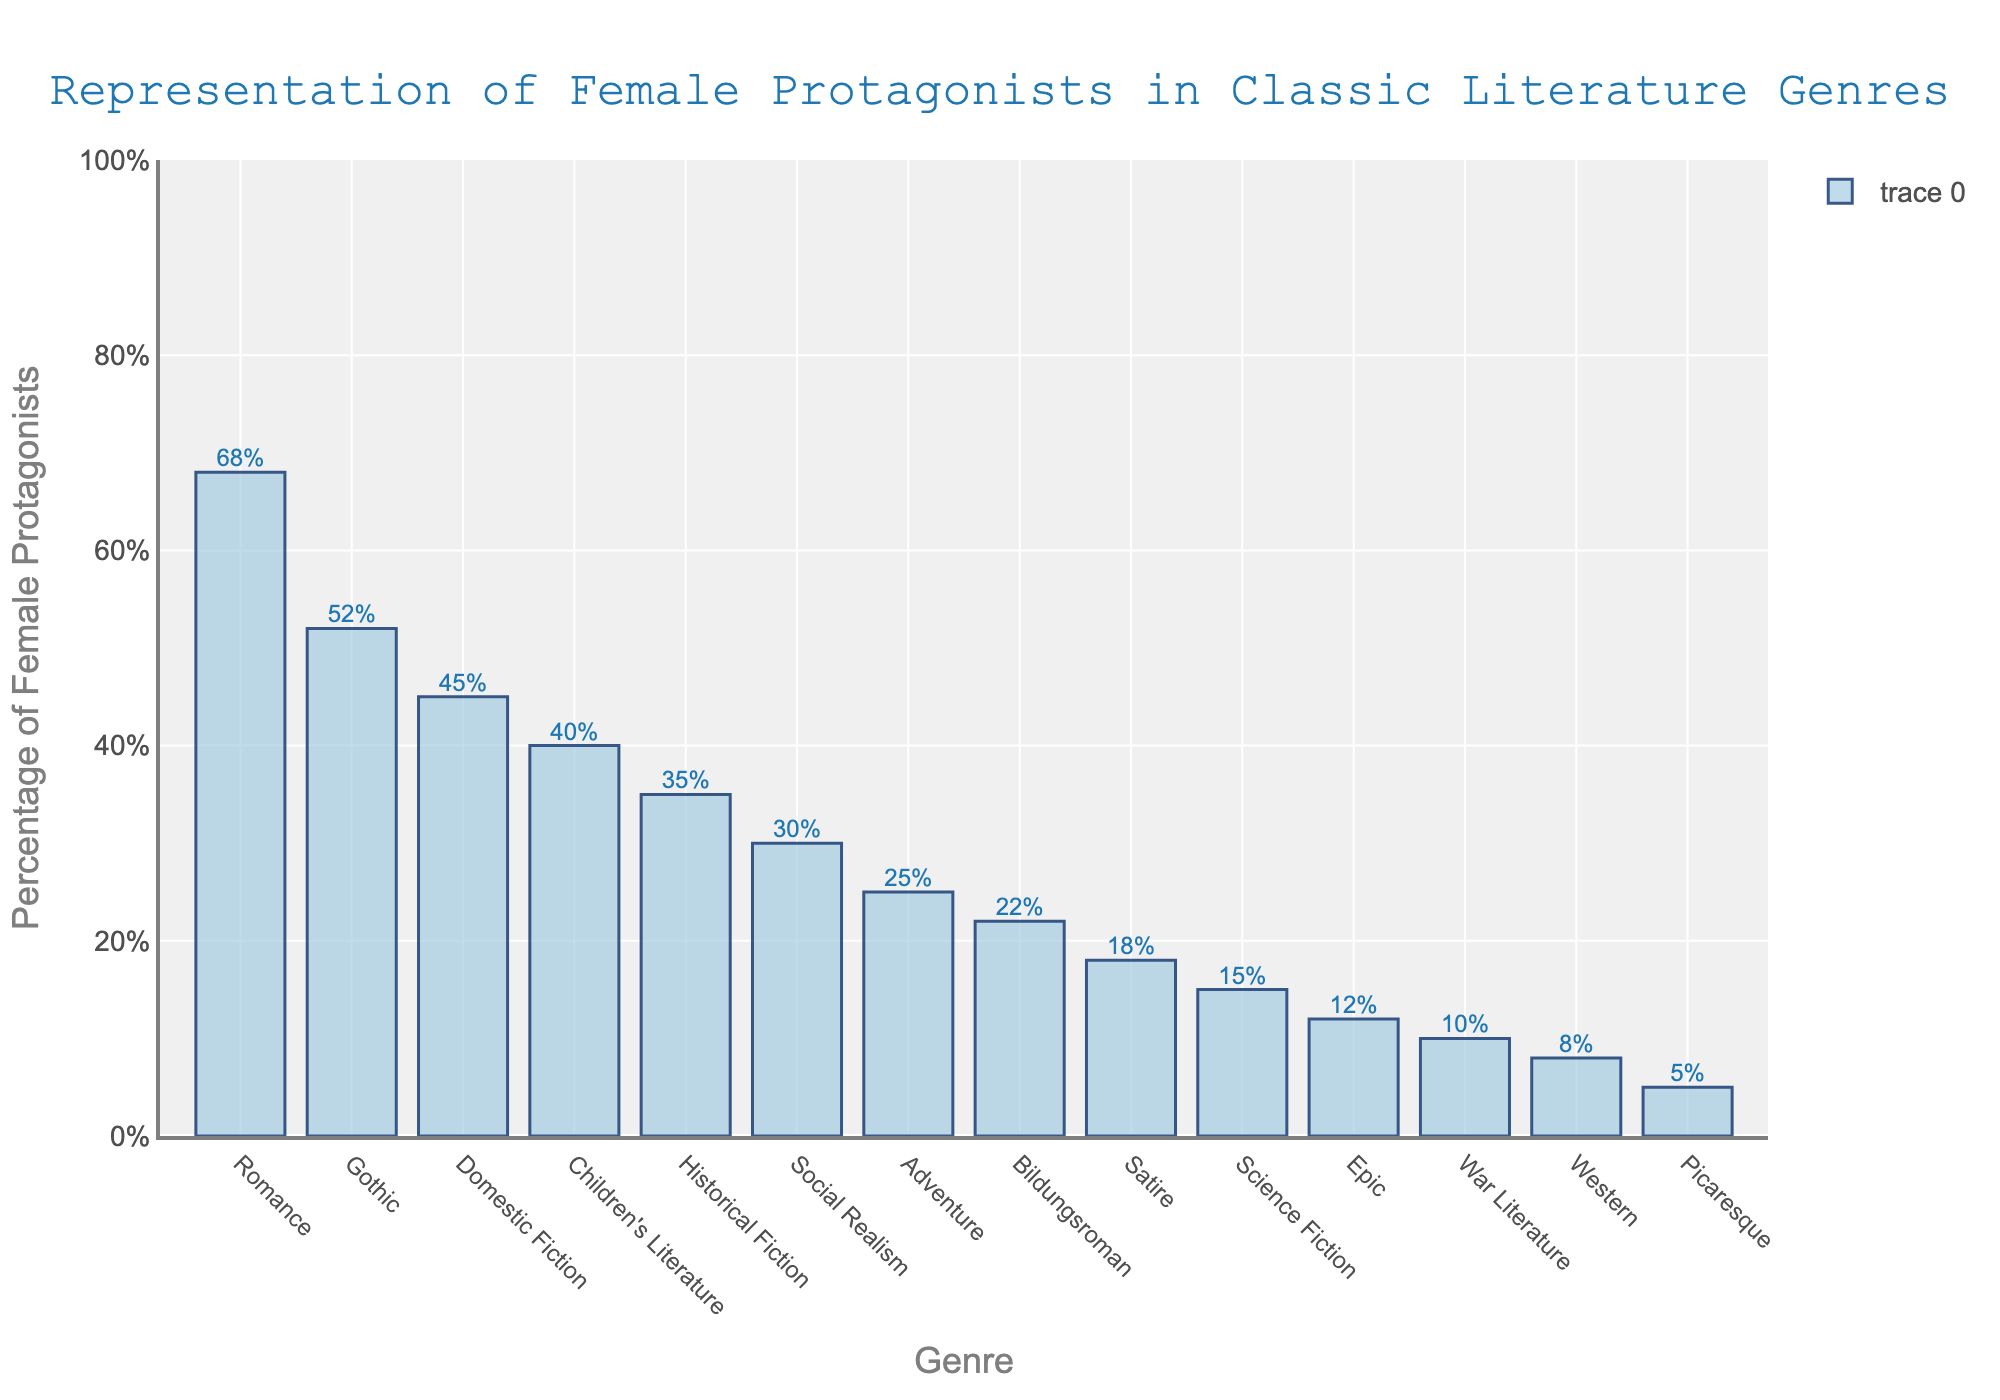What's the genre with the highest percentage of female protagonists? Look at the bar with the highest value. The tallest bar represents "Romance" with 68%.
Answer: Romance Which genre has a higher percentage of female protagonists: Gothic or Historical Fiction? Compare the heights of the bars for "Gothic" and "Historical Fiction". Gothic is at 52% while Historical Fiction is at 35%.
Answer: Gothic What's the difference in the percentage of female protagonists between Satire and Western? Subtract the value of Western from Satire. Satire is at 18% and Western is at 8%, so 18 - 8 = 10.
Answer: 10 What percentage of female protagonists does the genre Social Realism have? Look at the bar labeled "Social Realism" and the label above it. Social Realism has 30%.
Answer: 30% What's the average percentage of female protagonists in Adventure, Bildungsroman, and War Literature? Add the percentages and divide by the number of genres. (25 + 22 + 10) / 3 = 57 / 3 = 19.
Answer: 19 Which two genres have the smallest percentages of female protagonists? Look for the two shortest bars. The shortest are "Picaresque" (5%) and "Western" (8%).
Answer: Picaresque and Western Is the percentage of female protagonists in Children's Literature higher than in Domestic Fiction? Compare the heights of the bars for "Children's Literature" and "Domestic Fiction". Children's Literature is at 40%, Domestic Fiction is at 45%.
Answer: No How many genres have a percentage of female protagonists of 35% or more? Count the number of bars that reach or exceed the 35% line. Romance, Gothic, Domestic Fiction, and Children's Literature, Historical Fiction—5 genres.
Answer: 5 What is the median percentage of female protagonists among all genres listed? Arrange the percentages in ascending order and find the middle value. (5, 8, 10, 12, 15, 18, 22, 25, 30, 35, 40, 45, 52, 68). The middle values are 22 and 25; their average is (22 + 25) / 2 = 47/2 = 23.5.
Answer: 23.5 Identify the genre with the lowest percentage of female protagonists. Look at the shortest bar. The shortest bar represents "Picaresque" with 5%.
Answer: Picaresque 